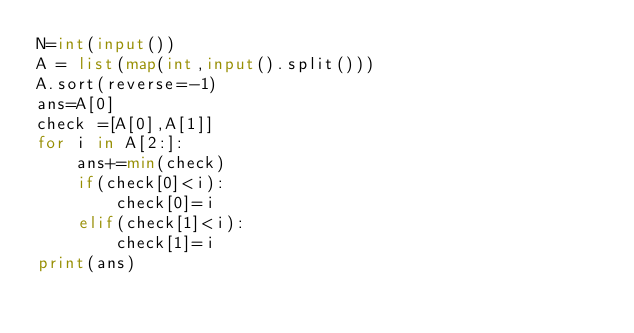Convert code to text. <code><loc_0><loc_0><loc_500><loc_500><_Python_>N=int(input())
A = list(map(int,input().split()))
A.sort(reverse=-1)
ans=A[0]
check =[A[0],A[1]]
for i in A[2:]:
    ans+=min(check)
    if(check[0]<i):
        check[0]=i
    elif(check[1]<i):
        check[1]=i
print(ans)
        </code> 